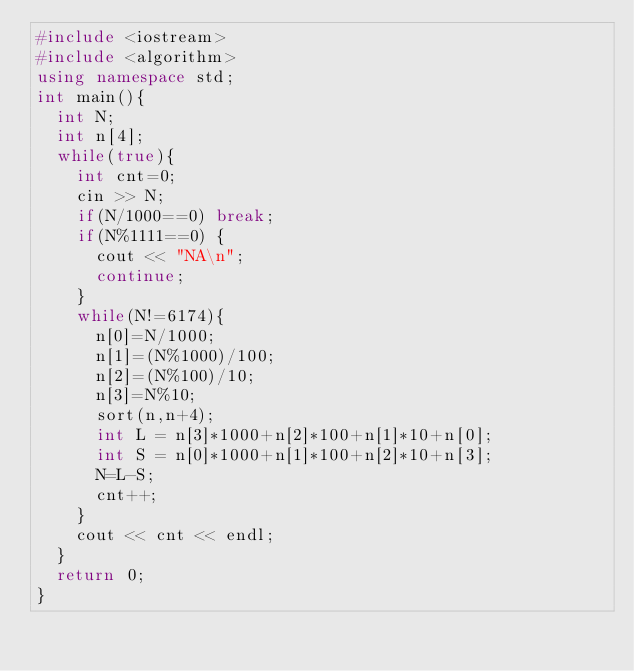Convert code to text. <code><loc_0><loc_0><loc_500><loc_500><_C++_>#include <iostream>
#include <algorithm> 
using namespace std;
int main(){
	int N; 
	int n[4];
	while(true){
		int cnt=0;
		cin >> N;
		if(N/1000==0) break;
		if(N%1111==0) {
			cout << "NA\n";
			continue;
		}
		while(N!=6174){
			n[0]=N/1000;
			n[1]=(N%1000)/100;
			n[2]=(N%100)/10;
			n[3]=N%10;
			sort(n,n+4);
			int L = n[3]*1000+n[2]*100+n[1]*10+n[0];
			int S = n[0]*1000+n[1]*100+n[2]*10+n[3];
			N=L-S;
			cnt++;
		}
		cout << cnt << endl;
	}
	return 0;
}</code> 